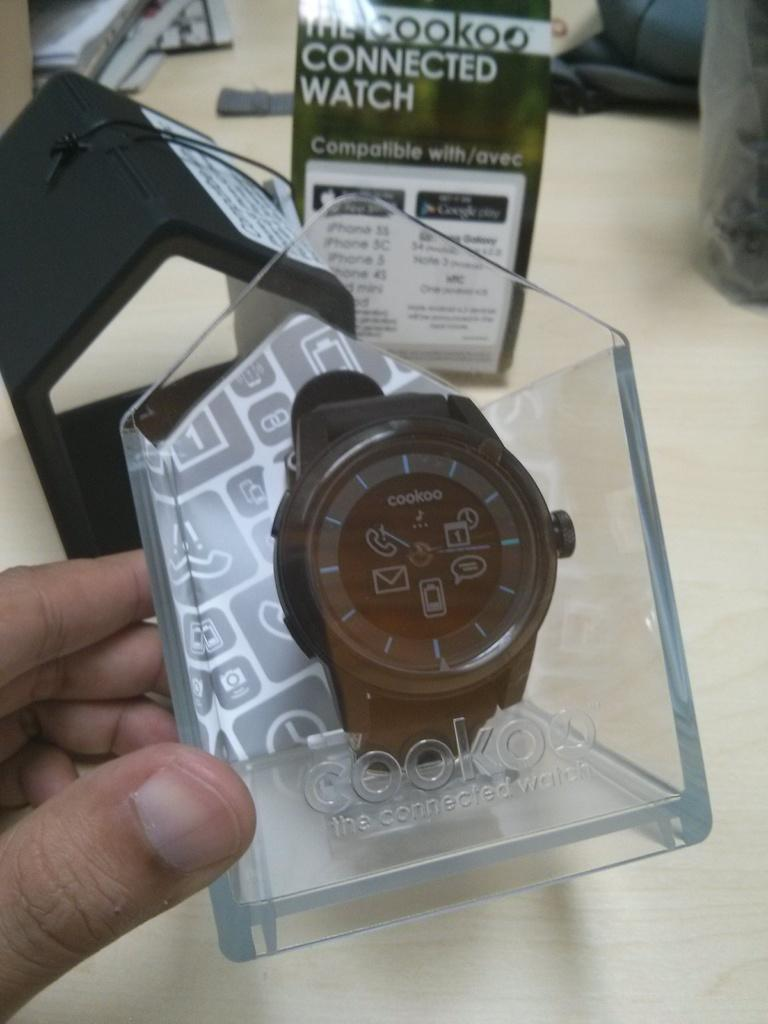Provide a one-sentence caption for the provided image. Cookoo watch is displayed in a clear case. 